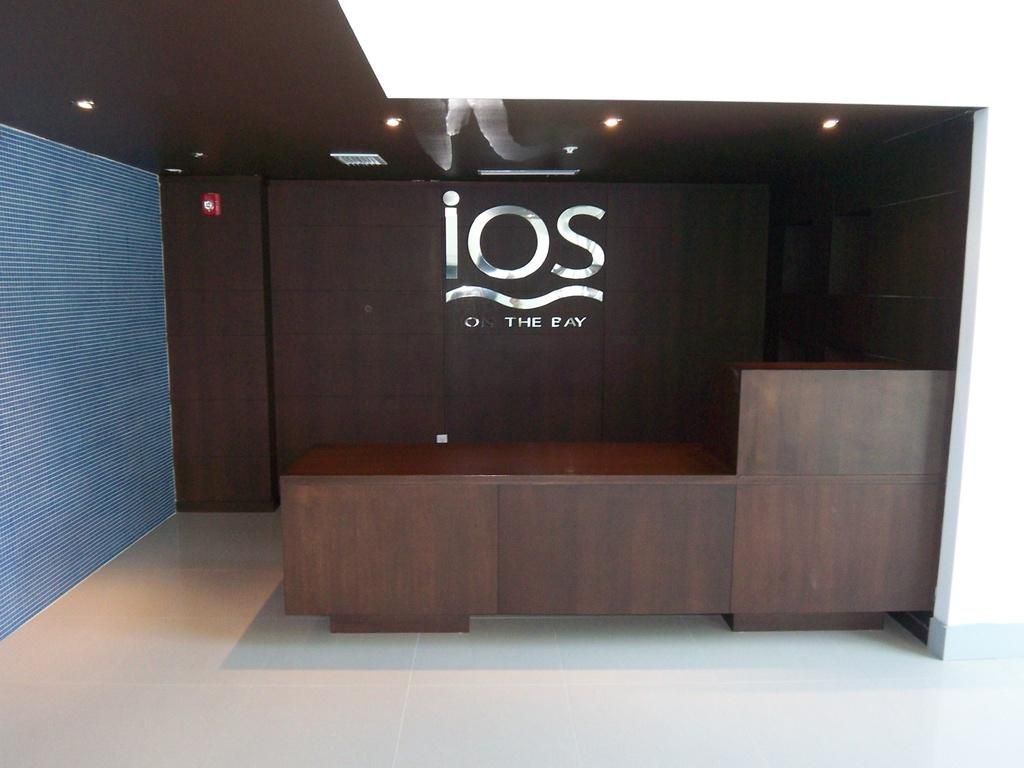What type of furniture is in the image? There is a wooden desk in the image. What can be seen on the wall behind the desk? There is a name on a wooden wall behind the desk. What else is on the wall besides the name? There are objects on the wall. Where are the lamps located in the image? The lamps are on the roof in the image. What type of clover is growing on the roof in the image? There is no clover visible in the image; the lamps are the only objects mentioned on the roof. 